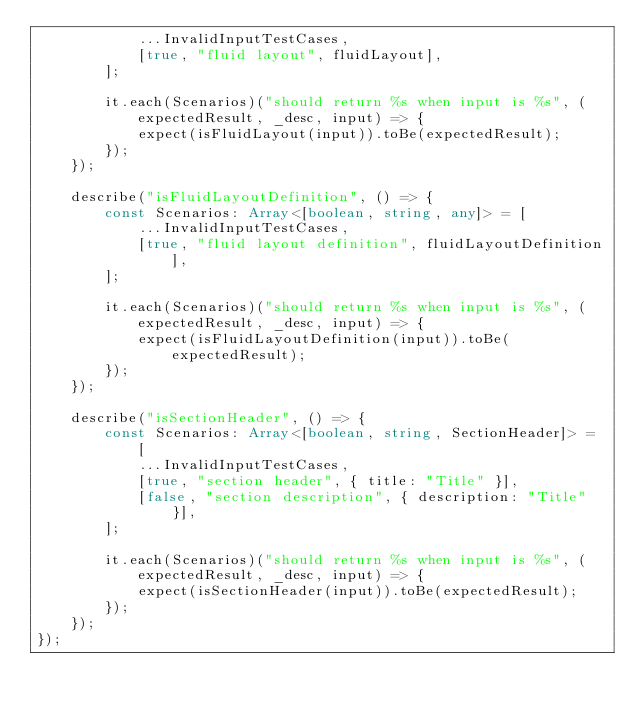<code> <loc_0><loc_0><loc_500><loc_500><_TypeScript_>            ...InvalidInputTestCases,
            [true, "fluid layout", fluidLayout],
        ];

        it.each(Scenarios)("should return %s when input is %s", (expectedResult, _desc, input) => {
            expect(isFluidLayout(input)).toBe(expectedResult);
        });
    });

    describe("isFluidLayoutDefinition", () => {
        const Scenarios: Array<[boolean, string, any]> = [
            ...InvalidInputTestCases,
            [true, "fluid layout definition", fluidLayoutDefinition],
        ];

        it.each(Scenarios)("should return %s when input is %s", (expectedResult, _desc, input) => {
            expect(isFluidLayoutDefinition(input)).toBe(expectedResult);
        });
    });

    describe("isSectionHeader", () => {
        const Scenarios: Array<[boolean, string, SectionHeader]> = [
            ...InvalidInputTestCases,
            [true, "section header", { title: "Title" }],
            [false, "section description", { description: "Title" }],
        ];

        it.each(Scenarios)("should return %s when input is %s", (expectedResult, _desc, input) => {
            expect(isSectionHeader(input)).toBe(expectedResult);
        });
    });
});
</code> 